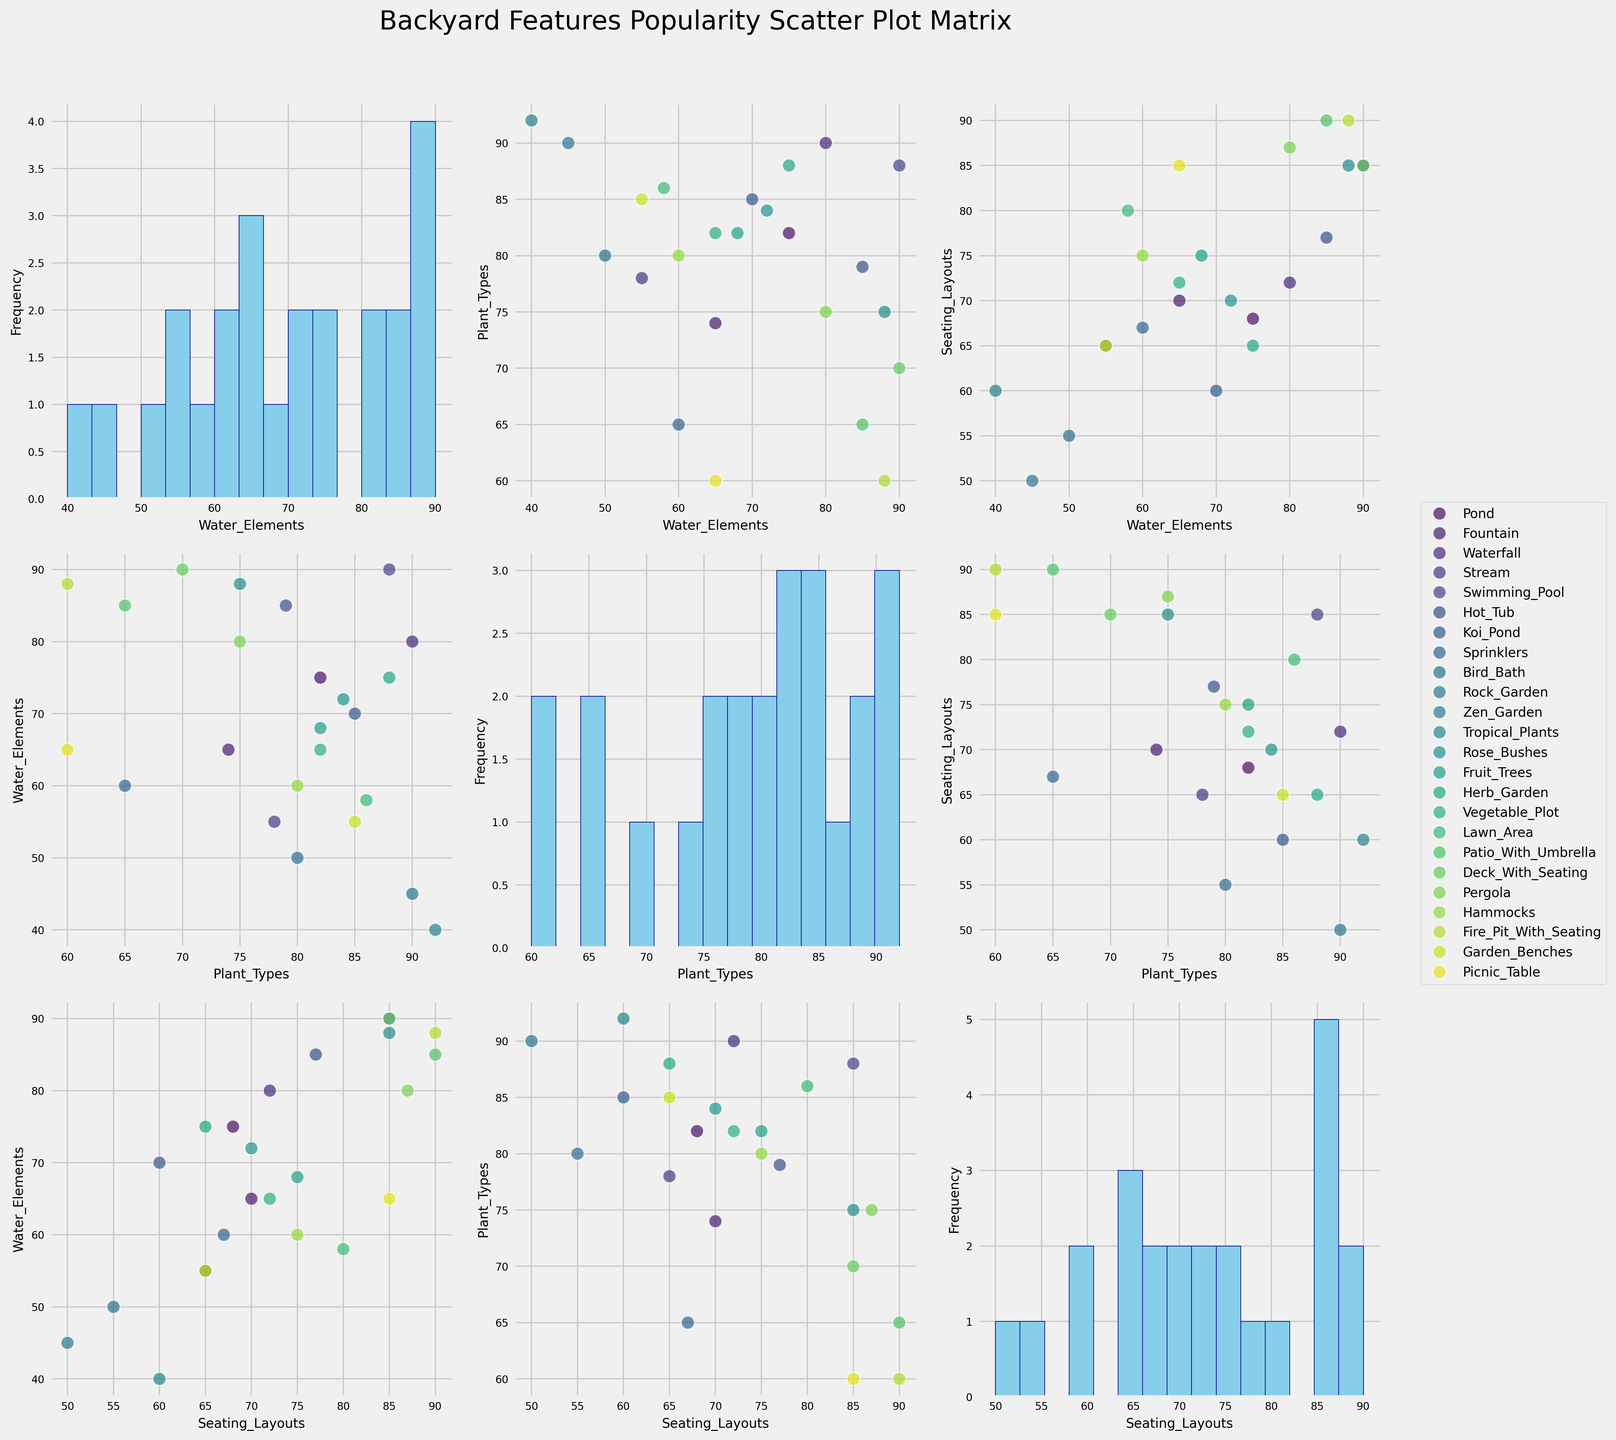What is the title of the scatter plot matrix? The title is typically located at the top of the figure. It serves to inform the viewer about what the data in the plot represents. By looking at the top of the figure, we see the title clearly stated as 'Backyard Features Popularity Scatter Plot Matrix'.
Answer: Backyard Features Popularity Scatter Plot Matrix How many features are plotted in the scatter plot matrix? The scatter plot matrix plots combinations of different features against each other. From the axis labels and scatter plots, we can observe that there are three features: Water Elements, Plant Types, and Seating Layouts.
Answer: Three Which feature has the highest popularity in the histogram plots? By examining the histograms along the diagonal of the scatter plot matrix, we look for the highest bar. The histogram for 'Popularity of Plant Types' shows the highest bar, indicating the highest popularity values overall.
Answer: Plant Types Is there a positive correlation between the popularity of water elements and plant types? To determine if there is a positive correlation, we look at the scatter plot between these two variables. If the points trend upwards, there is a positive correlation. In this case, the general trend of the points is upward sloping.
Answer: Yes Which feature is equally popular with seating layouts when its value is 90? By examining the scatter plots, we identify points where one feature is 90 and then check the corresponding values for seating layouts. The feature 'Swimming Pool' has a value of 90 in both water elements and seating layouts.
Answer: Swimming Pool What is the relationship between the popularity of plant types and seating layouts for tropical plants? We locate the point representing 'Tropical Plants' in the scatter plot of plant types vs. seating layouts and observe the coordinates. 'Tropical Plants' has high values for both plant types and seating layouts, indicating a strong positive correlation.
Answer: Strong Positive Which feature combinations show the least variation in their scatter plots? We identify scatter plots where the clustering of points is tight. The scatter plot of plant types vs. water elements shows a relatively tight clustering of points, indicating less variation.
Answer: Plant Types and Water Elements What can be inferred about the popularity of seating layouts for water elements features that are above 80? By observing the scatter plot between water elements and seating layouts, we look at points for water elements above 80. Most of these points also have relatively high seating layout values, indicating a positive correlation at higher ranges.
Answer: Positive Correlation at Higher Ranges For features that fall below 50 in popularity for plant types, what is their general trend in seating layouts? In the scatter plot of plant types vs. seating layouts, we focus on points where plant types have values below 50. We note their respective seating layout values and see that they generally cluster around lower seating layout values.
Answer: Lower Seating Layout Values 